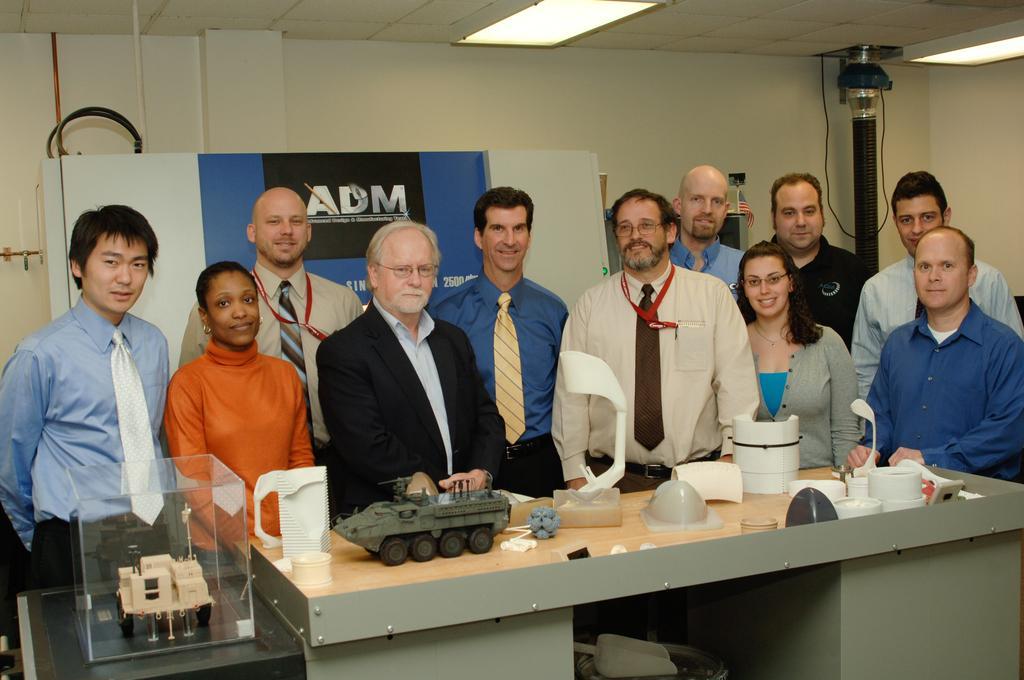Could you give a brief overview of what you see in this image? In this image we can see a group of persons. In front of the persons we can see few objects on the tables. Behind the persons we can see a wall, few objects and a banner. On the right side, we can see a pole with light. At the top we can see the roof with lights. 